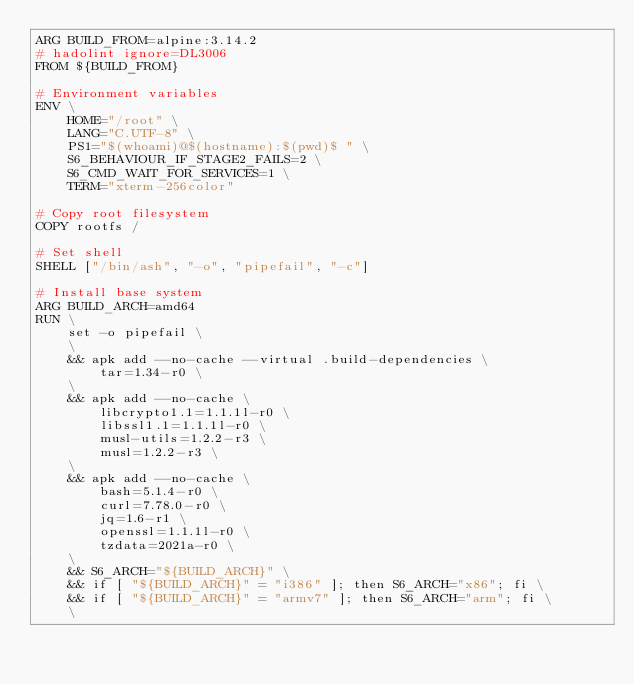Convert code to text. <code><loc_0><loc_0><loc_500><loc_500><_Dockerfile_>ARG BUILD_FROM=alpine:3.14.2
# hadolint ignore=DL3006
FROM ${BUILD_FROM}

# Environment variables
ENV \
    HOME="/root" \
    LANG="C.UTF-8" \
    PS1="$(whoami)@$(hostname):$(pwd)$ " \
    S6_BEHAVIOUR_IF_STAGE2_FAILS=2 \
    S6_CMD_WAIT_FOR_SERVICES=1 \
    TERM="xterm-256color"

# Copy root filesystem
COPY rootfs /

# Set shell
SHELL ["/bin/ash", "-o", "pipefail", "-c"]

# Install base system
ARG BUILD_ARCH=amd64
RUN \
    set -o pipefail \
    \
    && apk add --no-cache --virtual .build-dependencies \
        tar=1.34-r0 \
    \
    && apk add --no-cache \
        libcrypto1.1=1.1.1l-r0 \
        libssl1.1=1.1.1l-r0 \
        musl-utils=1.2.2-r3 \
        musl=1.2.2-r3 \
    \
    && apk add --no-cache \
        bash=5.1.4-r0 \
        curl=7.78.0-r0 \
        jq=1.6-r1 \
        openssl=1.1.1l-r0 \
        tzdata=2021a-r0 \
    \
    && S6_ARCH="${BUILD_ARCH}" \
    && if [ "${BUILD_ARCH}" = "i386" ]; then S6_ARCH="x86"; fi \
    && if [ "${BUILD_ARCH}" = "armv7" ]; then S6_ARCH="arm"; fi \
    \</code> 